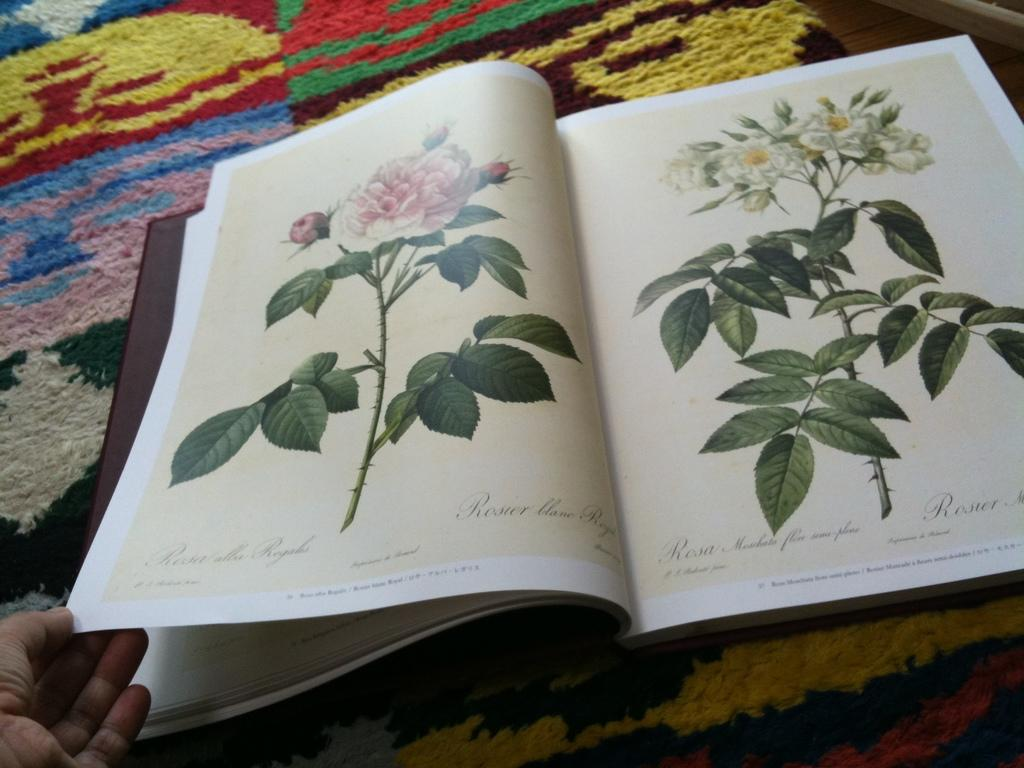<image>
Provide a brief description of the given image. A book is open to a page identifying flowers, Rosier Blanc Royal written in script on the bottom right of the left page. 